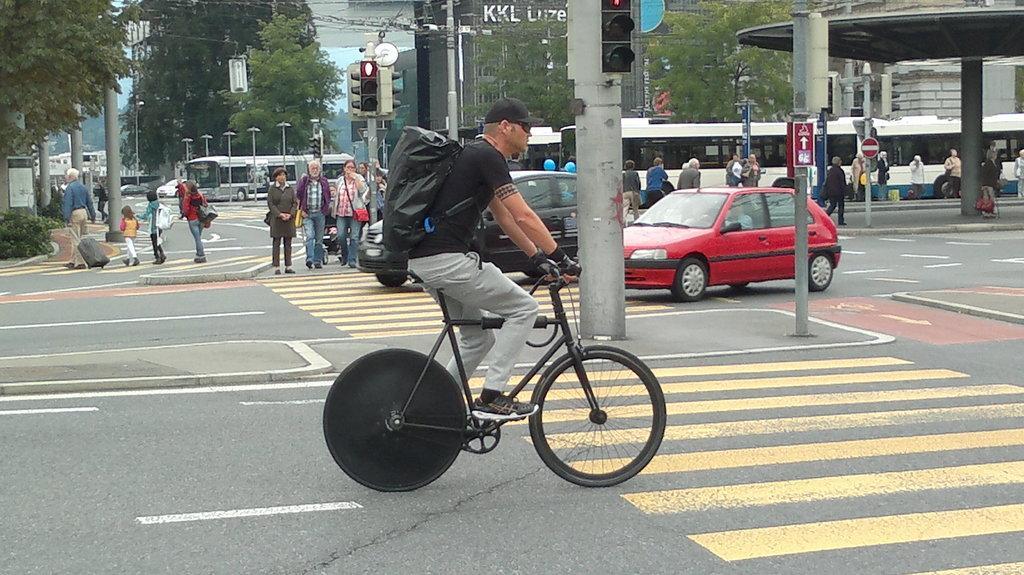In one or two sentences, can you explain what this image depicts? In this image i can see a man riding a bicycle wearing a bag and a hat. In the background i can see few people crossing the road and few people standing, and also few vehicles, trees, buildings and a traffic signal. 